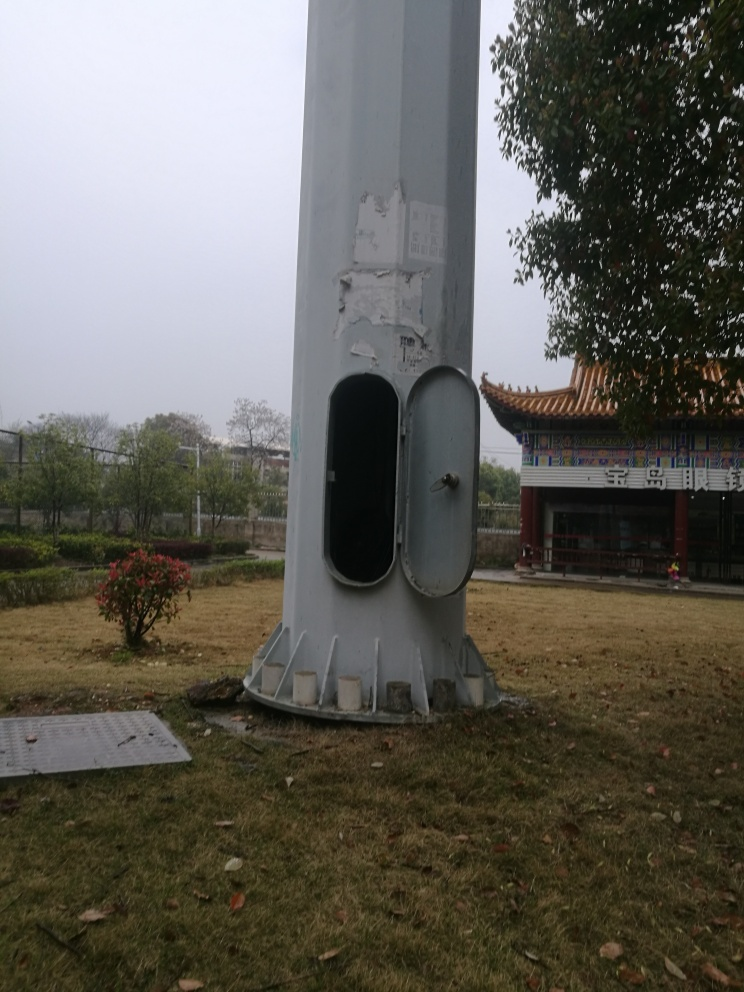What is the architectural style of the building in the background? The visible architecture includes a pagoda-style roof with curved eaves, richly decorated with what seem to be traditional East Asian motifs, suggesting an influence from Chinese architectural styles. 